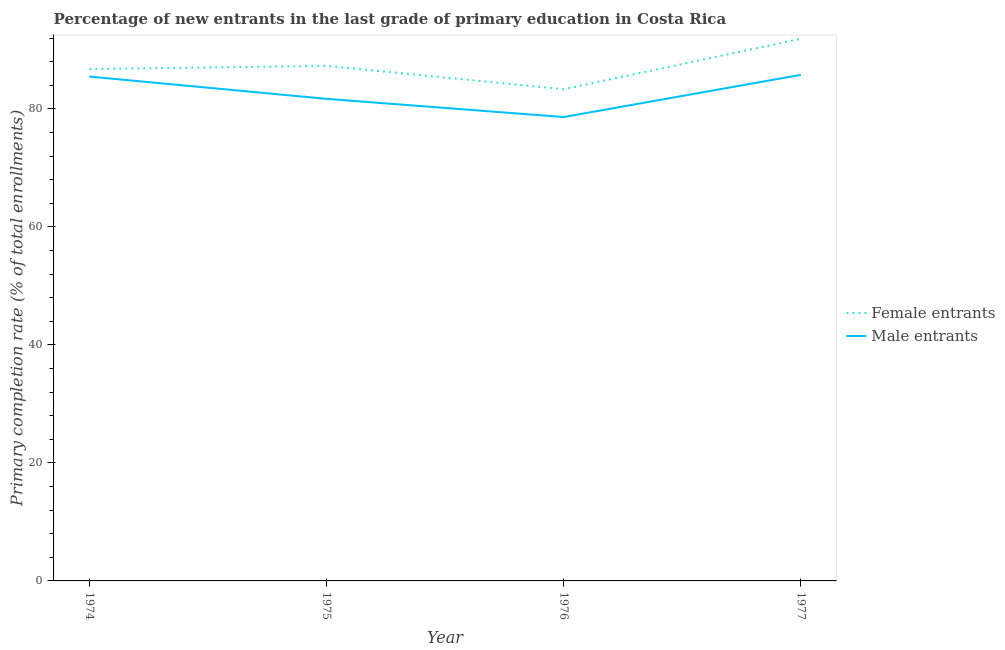How many different coloured lines are there?
Offer a terse response. 2. What is the primary completion rate of male entrants in 1975?
Provide a short and direct response. 81.71. Across all years, what is the maximum primary completion rate of female entrants?
Offer a very short reply. 91.89. Across all years, what is the minimum primary completion rate of male entrants?
Keep it short and to the point. 78.63. In which year was the primary completion rate of male entrants maximum?
Ensure brevity in your answer.  1977. In which year was the primary completion rate of female entrants minimum?
Provide a short and direct response. 1976. What is the total primary completion rate of female entrants in the graph?
Your answer should be compact. 349.3. What is the difference between the primary completion rate of female entrants in 1974 and that in 1977?
Make the answer very short. -5.13. What is the difference between the primary completion rate of male entrants in 1976 and the primary completion rate of female entrants in 1975?
Make the answer very short. -8.67. What is the average primary completion rate of female entrants per year?
Provide a succinct answer. 87.32. In the year 1977, what is the difference between the primary completion rate of female entrants and primary completion rate of male entrants?
Ensure brevity in your answer.  6.11. What is the ratio of the primary completion rate of female entrants in 1974 to that in 1976?
Give a very brief answer. 1.04. Is the primary completion rate of female entrants in 1976 less than that in 1977?
Your answer should be compact. Yes. Is the difference between the primary completion rate of female entrants in 1974 and 1977 greater than the difference between the primary completion rate of male entrants in 1974 and 1977?
Give a very brief answer. No. What is the difference between the highest and the second highest primary completion rate of female entrants?
Give a very brief answer. 4.59. What is the difference between the highest and the lowest primary completion rate of female entrants?
Provide a short and direct response. 8.55. Is the sum of the primary completion rate of female entrants in 1975 and 1977 greater than the maximum primary completion rate of male entrants across all years?
Make the answer very short. Yes. How many years are there in the graph?
Give a very brief answer. 4. What is the difference between two consecutive major ticks on the Y-axis?
Give a very brief answer. 20. Where does the legend appear in the graph?
Your answer should be compact. Center right. How are the legend labels stacked?
Offer a terse response. Vertical. What is the title of the graph?
Offer a terse response. Percentage of new entrants in the last grade of primary education in Costa Rica. What is the label or title of the Y-axis?
Your response must be concise. Primary completion rate (% of total enrollments). What is the Primary completion rate (% of total enrollments) of Female entrants in 1974?
Provide a short and direct response. 86.76. What is the Primary completion rate (% of total enrollments) in Male entrants in 1974?
Give a very brief answer. 85.49. What is the Primary completion rate (% of total enrollments) of Female entrants in 1975?
Offer a terse response. 87.3. What is the Primary completion rate (% of total enrollments) of Male entrants in 1975?
Give a very brief answer. 81.71. What is the Primary completion rate (% of total enrollments) in Female entrants in 1976?
Your answer should be very brief. 83.34. What is the Primary completion rate (% of total enrollments) in Male entrants in 1976?
Provide a short and direct response. 78.63. What is the Primary completion rate (% of total enrollments) in Female entrants in 1977?
Offer a very short reply. 91.89. What is the Primary completion rate (% of total enrollments) of Male entrants in 1977?
Make the answer very short. 85.78. Across all years, what is the maximum Primary completion rate (% of total enrollments) of Female entrants?
Your response must be concise. 91.89. Across all years, what is the maximum Primary completion rate (% of total enrollments) of Male entrants?
Keep it short and to the point. 85.78. Across all years, what is the minimum Primary completion rate (% of total enrollments) of Female entrants?
Your answer should be compact. 83.34. Across all years, what is the minimum Primary completion rate (% of total enrollments) of Male entrants?
Make the answer very short. 78.63. What is the total Primary completion rate (% of total enrollments) in Female entrants in the graph?
Your response must be concise. 349.3. What is the total Primary completion rate (% of total enrollments) of Male entrants in the graph?
Ensure brevity in your answer.  331.62. What is the difference between the Primary completion rate (% of total enrollments) of Female entrants in 1974 and that in 1975?
Provide a succinct answer. -0.54. What is the difference between the Primary completion rate (% of total enrollments) in Male entrants in 1974 and that in 1975?
Provide a short and direct response. 3.78. What is the difference between the Primary completion rate (% of total enrollments) of Female entrants in 1974 and that in 1976?
Give a very brief answer. 3.42. What is the difference between the Primary completion rate (% of total enrollments) in Male entrants in 1974 and that in 1976?
Ensure brevity in your answer.  6.86. What is the difference between the Primary completion rate (% of total enrollments) of Female entrants in 1974 and that in 1977?
Your answer should be very brief. -5.13. What is the difference between the Primary completion rate (% of total enrollments) of Male entrants in 1974 and that in 1977?
Make the answer very short. -0.29. What is the difference between the Primary completion rate (% of total enrollments) of Female entrants in 1975 and that in 1976?
Keep it short and to the point. 3.96. What is the difference between the Primary completion rate (% of total enrollments) in Male entrants in 1975 and that in 1976?
Offer a terse response. 3.08. What is the difference between the Primary completion rate (% of total enrollments) in Female entrants in 1975 and that in 1977?
Give a very brief answer. -4.59. What is the difference between the Primary completion rate (% of total enrollments) of Male entrants in 1975 and that in 1977?
Give a very brief answer. -4.07. What is the difference between the Primary completion rate (% of total enrollments) in Female entrants in 1976 and that in 1977?
Give a very brief answer. -8.55. What is the difference between the Primary completion rate (% of total enrollments) of Male entrants in 1976 and that in 1977?
Your answer should be very brief. -7.15. What is the difference between the Primary completion rate (% of total enrollments) in Female entrants in 1974 and the Primary completion rate (% of total enrollments) in Male entrants in 1975?
Provide a succinct answer. 5.05. What is the difference between the Primary completion rate (% of total enrollments) in Female entrants in 1974 and the Primary completion rate (% of total enrollments) in Male entrants in 1976?
Make the answer very short. 8.13. What is the difference between the Primary completion rate (% of total enrollments) in Female entrants in 1974 and the Primary completion rate (% of total enrollments) in Male entrants in 1977?
Keep it short and to the point. 0.98. What is the difference between the Primary completion rate (% of total enrollments) in Female entrants in 1975 and the Primary completion rate (% of total enrollments) in Male entrants in 1976?
Make the answer very short. 8.67. What is the difference between the Primary completion rate (% of total enrollments) in Female entrants in 1975 and the Primary completion rate (% of total enrollments) in Male entrants in 1977?
Provide a succinct answer. 1.52. What is the difference between the Primary completion rate (% of total enrollments) of Female entrants in 1976 and the Primary completion rate (% of total enrollments) of Male entrants in 1977?
Give a very brief answer. -2.44. What is the average Primary completion rate (% of total enrollments) in Female entrants per year?
Your answer should be compact. 87.32. What is the average Primary completion rate (% of total enrollments) of Male entrants per year?
Your answer should be very brief. 82.9. In the year 1974, what is the difference between the Primary completion rate (% of total enrollments) of Female entrants and Primary completion rate (% of total enrollments) of Male entrants?
Give a very brief answer. 1.27. In the year 1975, what is the difference between the Primary completion rate (% of total enrollments) of Female entrants and Primary completion rate (% of total enrollments) of Male entrants?
Provide a succinct answer. 5.59. In the year 1976, what is the difference between the Primary completion rate (% of total enrollments) of Female entrants and Primary completion rate (% of total enrollments) of Male entrants?
Ensure brevity in your answer.  4.71. In the year 1977, what is the difference between the Primary completion rate (% of total enrollments) of Female entrants and Primary completion rate (% of total enrollments) of Male entrants?
Your response must be concise. 6.11. What is the ratio of the Primary completion rate (% of total enrollments) of Female entrants in 1974 to that in 1975?
Your response must be concise. 0.99. What is the ratio of the Primary completion rate (% of total enrollments) in Male entrants in 1974 to that in 1975?
Provide a short and direct response. 1.05. What is the ratio of the Primary completion rate (% of total enrollments) in Female entrants in 1974 to that in 1976?
Offer a terse response. 1.04. What is the ratio of the Primary completion rate (% of total enrollments) of Male entrants in 1974 to that in 1976?
Provide a succinct answer. 1.09. What is the ratio of the Primary completion rate (% of total enrollments) of Female entrants in 1974 to that in 1977?
Give a very brief answer. 0.94. What is the ratio of the Primary completion rate (% of total enrollments) of Female entrants in 1975 to that in 1976?
Ensure brevity in your answer.  1.05. What is the ratio of the Primary completion rate (% of total enrollments) of Male entrants in 1975 to that in 1976?
Provide a short and direct response. 1.04. What is the ratio of the Primary completion rate (% of total enrollments) of Male entrants in 1975 to that in 1977?
Keep it short and to the point. 0.95. What is the ratio of the Primary completion rate (% of total enrollments) of Female entrants in 1976 to that in 1977?
Give a very brief answer. 0.91. What is the ratio of the Primary completion rate (% of total enrollments) of Male entrants in 1976 to that in 1977?
Make the answer very short. 0.92. What is the difference between the highest and the second highest Primary completion rate (% of total enrollments) of Female entrants?
Ensure brevity in your answer.  4.59. What is the difference between the highest and the second highest Primary completion rate (% of total enrollments) of Male entrants?
Your response must be concise. 0.29. What is the difference between the highest and the lowest Primary completion rate (% of total enrollments) in Female entrants?
Make the answer very short. 8.55. What is the difference between the highest and the lowest Primary completion rate (% of total enrollments) in Male entrants?
Your answer should be compact. 7.15. 